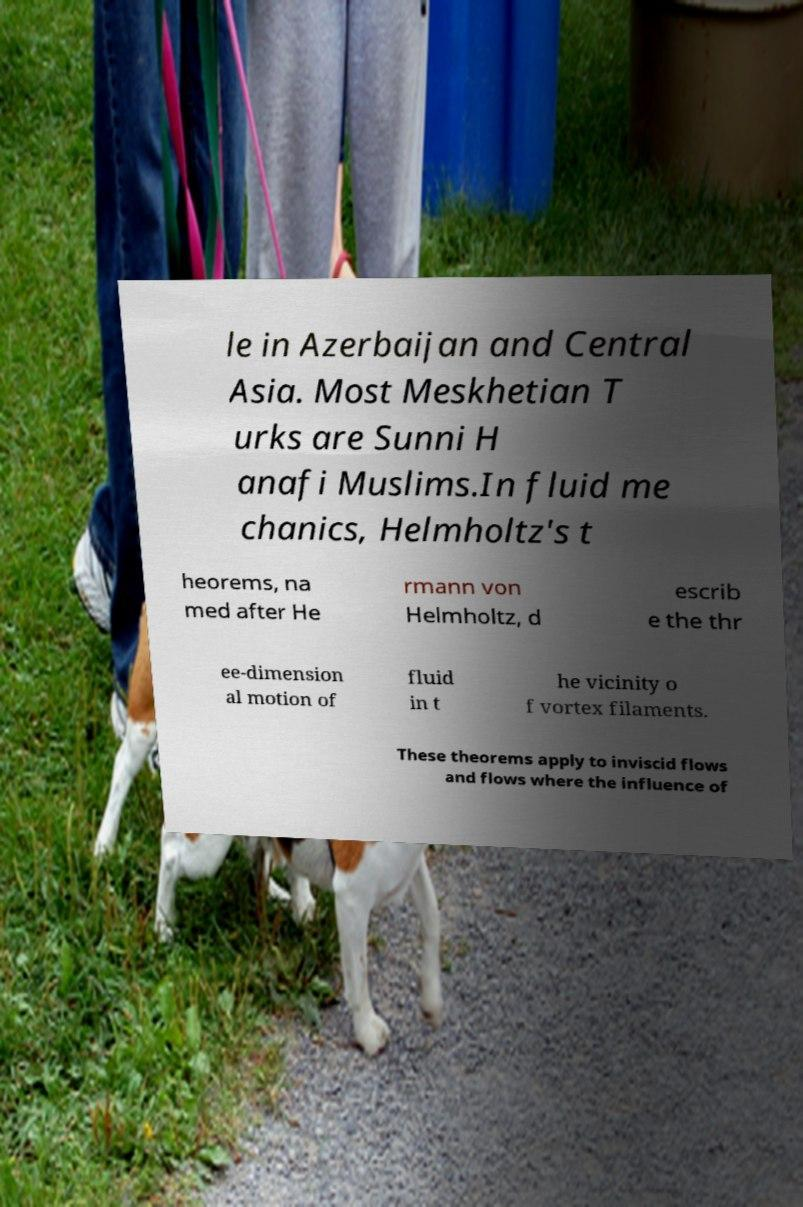I need the written content from this picture converted into text. Can you do that? le in Azerbaijan and Central Asia. Most Meskhetian T urks are Sunni H anafi Muslims.In fluid me chanics, Helmholtz's t heorems, na med after He rmann von Helmholtz, d escrib e the thr ee-dimension al motion of fluid in t he vicinity o f vortex filaments. These theorems apply to inviscid flows and flows where the influence of 